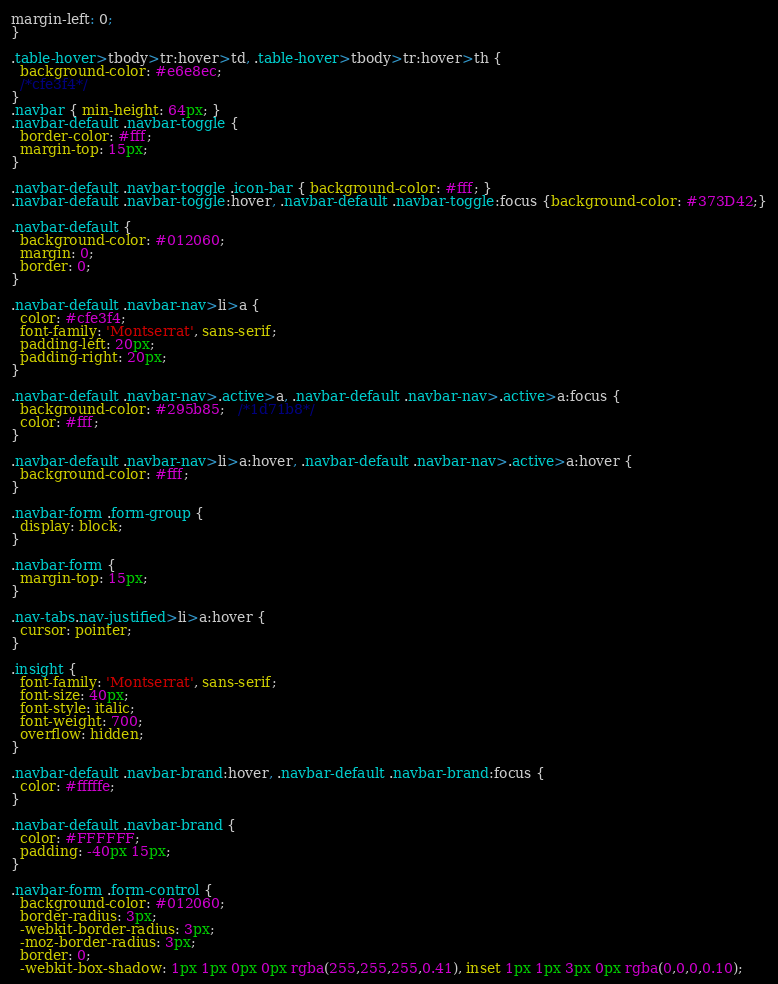<code> <loc_0><loc_0><loc_500><loc_500><_CSS_>margin-left: 0;
}

.table-hover>tbody>tr:hover>td, .table-hover>tbody>tr:hover>th {
  background-color: #e6e8ec;
  /*cfe3f4*/
}
.navbar { min-height: 64px; }
.navbar-default .navbar-toggle {
  border-color: #fff;
  margin-top: 15px;
}

.navbar-default .navbar-toggle .icon-bar { background-color: #fff; }
.navbar-default .navbar-toggle:hover, .navbar-default .navbar-toggle:focus {background-color: #373D42;}

.navbar-default {
  background-color: #012060;
  margin: 0;
  border: 0;
}

.navbar-default .navbar-nav>li>a {
  color: #cfe3f4;
  font-family: 'Montserrat', sans-serif;
  padding-left: 20px;
  padding-right: 20px;
}

.navbar-default .navbar-nav>.active>a, .navbar-default .navbar-nav>.active>a:focus {
  background-color: #295b85;   /*1d71b8*/
  color: #fff;
}

.navbar-default .navbar-nav>li>a:hover, .navbar-default .navbar-nav>.active>a:hover {
  background-color: #fff;
}

.navbar-form .form-group {
  display: block;
}

.navbar-form {
  margin-top: 15px;
}

.nav-tabs.nav-justified>li>a:hover {
  cursor: pointer;
}

.insight {
  font-family: 'Montserrat', sans-serif;
  font-size: 40px;
  font-style: italic;
  font-weight: 700;
  overflow: hidden;
}

.navbar-default .navbar-brand:hover, .navbar-default .navbar-brand:focus {
  color: #fffffe;
}

.navbar-default .navbar-brand {
  color: #FFFFFF;
  padding: -40px 15px;
}

.navbar-form .form-control {
  background-color: #012060;
  border-radius: 3px;
  -webkit-border-radius: 3px;
  -moz-border-radius: 3px;
  border: 0;
  -webkit-box-shadow: 1px 1px 0px 0px rgba(255,255,255,0.41), inset 1px 1px 3px 0px rgba(0,0,0,0.10);</code> 